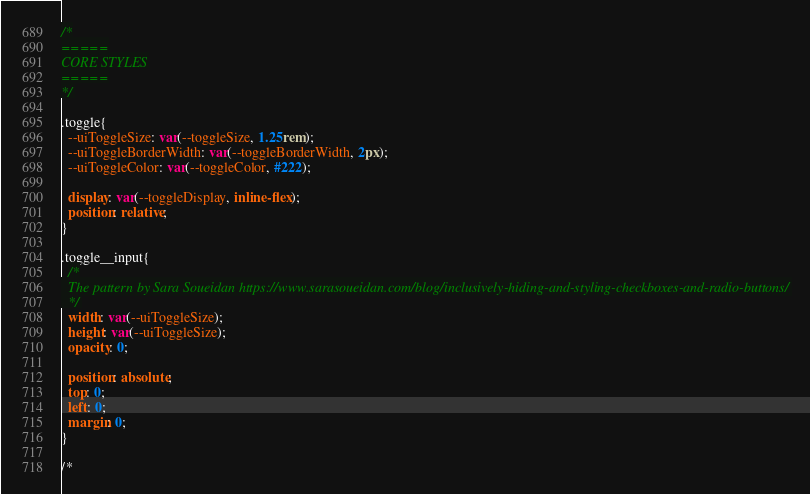Convert code to text. <code><loc_0><loc_0><loc_500><loc_500><_CSS_>
/*
=====
CORE STYLES
=====
*/

.toggle{
  --uiToggleSize: var(--toggleSize, 1.25rem);
  --uiToggleBorderWidth: var(--toggleBorderWidth, 2px);
  --uiToggleColor: var(--toggleColor, #222);

  display: var(--toggleDisplay, inline-flex);
  position: relative;
}

.toggle__input{
  /*
  The pattern by Sara Soueidan https://www.sarasoueidan.com/blog/inclusively-hiding-and-styling-checkboxes-and-radio-buttons/
  */
  width: var(--uiToggleSize);
  height: var(--uiToggleSize);
  opacity: 0;

  position: absolute;
  top: 0;
  left: 0;
  margin: 0;
}

/*</code> 